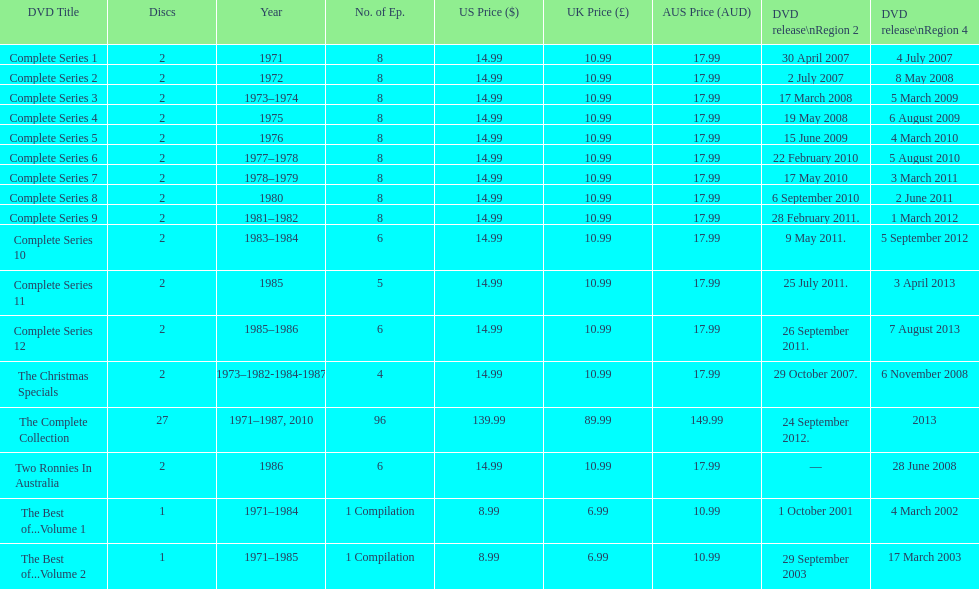Dvd shorter than 5 episodes The Christmas Specials. 